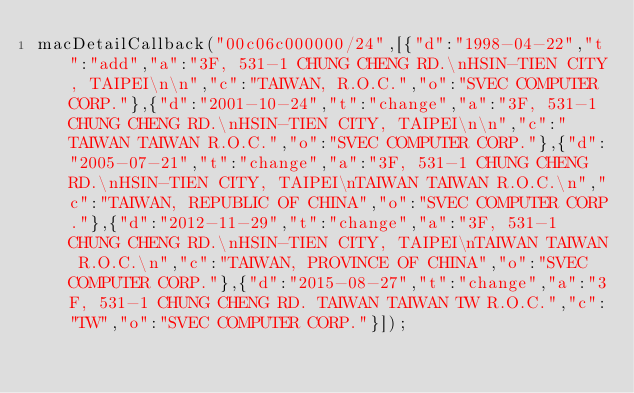<code> <loc_0><loc_0><loc_500><loc_500><_JavaScript_>macDetailCallback("00c06c000000/24",[{"d":"1998-04-22","t":"add","a":"3F, 531-1 CHUNG CHENG RD.\nHSIN-TIEN CITY, TAIPEI\n\n","c":"TAIWAN, R.O.C.","o":"SVEC COMPUTER CORP."},{"d":"2001-10-24","t":"change","a":"3F, 531-1 CHUNG CHENG RD.\nHSIN-TIEN CITY, TAIPEI\n\n","c":"TAIWAN TAIWAN R.O.C.","o":"SVEC COMPUTER CORP."},{"d":"2005-07-21","t":"change","a":"3F, 531-1 CHUNG CHENG RD.\nHSIN-TIEN CITY, TAIPEI\nTAIWAN TAIWAN R.O.C.\n","c":"TAIWAN, REPUBLIC OF CHINA","o":"SVEC COMPUTER CORP."},{"d":"2012-11-29","t":"change","a":"3F, 531-1 CHUNG CHENG RD.\nHSIN-TIEN CITY, TAIPEI\nTAIWAN TAIWAN R.O.C.\n","c":"TAIWAN, PROVINCE OF CHINA","o":"SVEC COMPUTER CORP."},{"d":"2015-08-27","t":"change","a":"3F, 531-1 CHUNG CHENG RD. TAIWAN TAIWAN TW R.O.C.","c":"TW","o":"SVEC COMPUTER CORP."}]);
</code> 